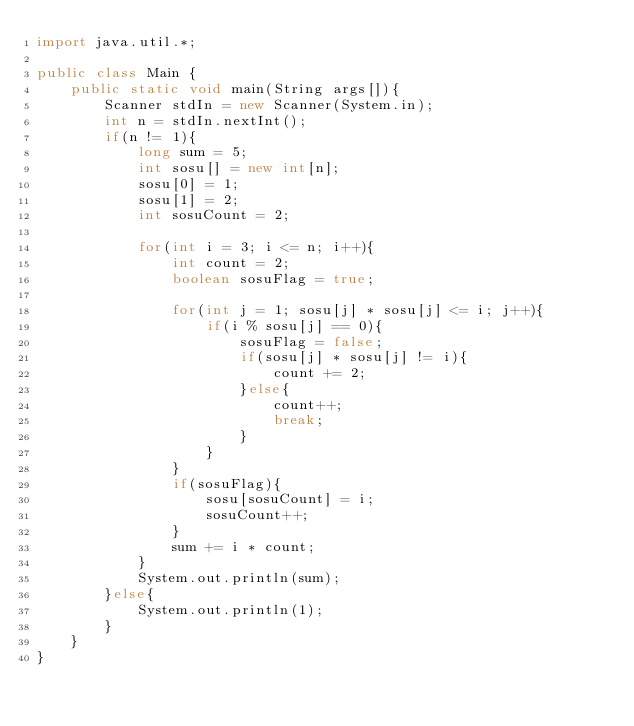<code> <loc_0><loc_0><loc_500><loc_500><_Java_>import java.util.*;

public class Main {
    public static void main(String args[]){
        Scanner stdIn = new Scanner(System.in);
        int n = stdIn.nextInt();
        if(n != 1){
            long sum = 5;
            int sosu[] = new int[n];
            sosu[0] = 1;
            sosu[1] = 2;
            int sosuCount = 2;
            
            for(int i = 3; i <= n; i++){
                int count = 2;
                boolean sosuFlag = true;
                
                for(int j = 1; sosu[j] * sosu[j] <= i; j++){
                    if(i % sosu[j] == 0){
                        sosuFlag = false;
                        if(sosu[j] * sosu[j] != i){
                            count += 2;
                        }else{
                            count++;
                            break;
                        }
                    }
                }
                if(sosuFlag){
                    sosu[sosuCount] = i;
                    sosuCount++;
                }
                sum += i * count;
            }
            System.out.println(sum);
        }else{
            System.out.println(1);
        }
    }
}
</code> 